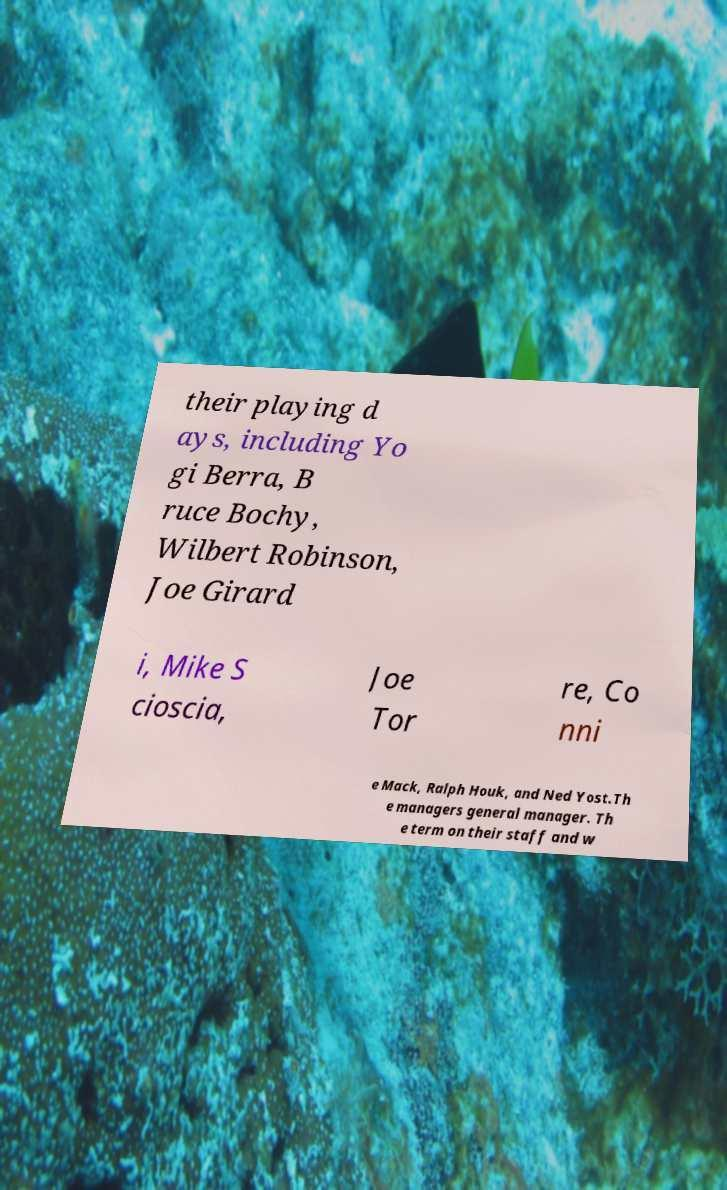Please read and relay the text visible in this image. What does it say? their playing d ays, including Yo gi Berra, B ruce Bochy, Wilbert Robinson, Joe Girard i, Mike S cioscia, Joe Tor re, Co nni e Mack, Ralph Houk, and Ned Yost.Th e managers general manager. Th e term on their staff and w 